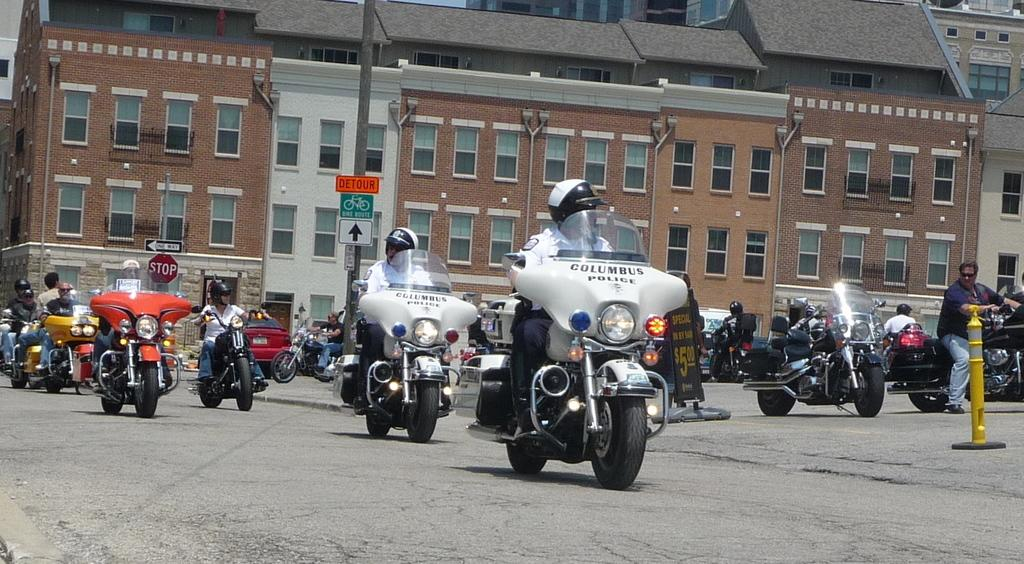What are the people in the image doing? The people in the image are riding motorcycles. How many people can be seen in the image? The number of people is not specified, but there is a group of people in the image. What can be seen in the background of the image? There are buildings visible in the background of the image. What type of lunch is being served in the garden in the image? There is no lunch or garden present in the image; it features a group of people riding motorcycles with buildings in the background. 